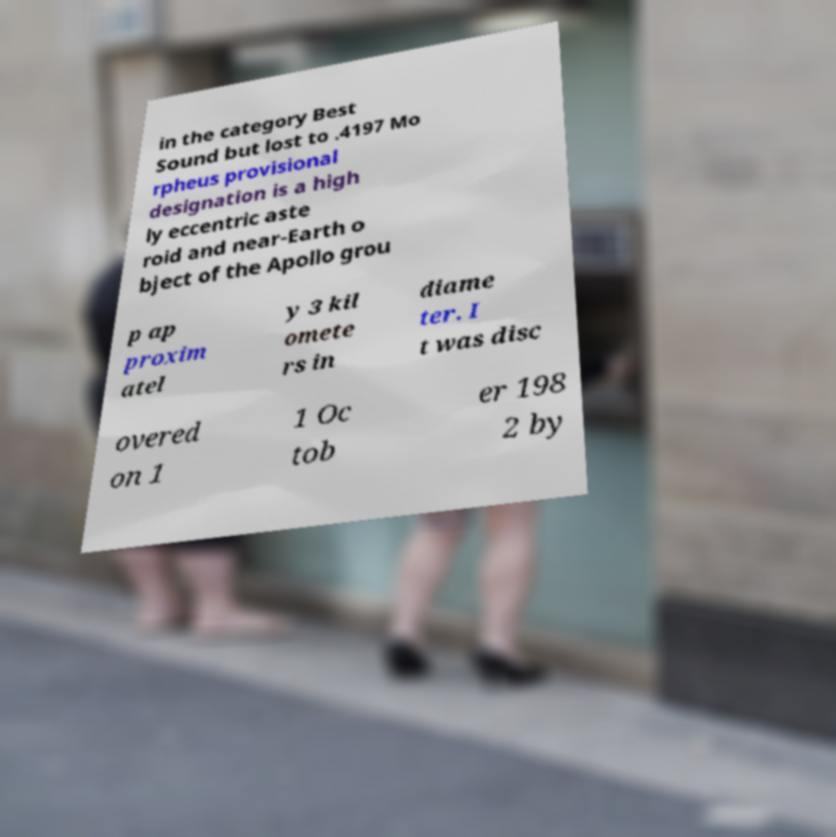What messages or text are displayed in this image? I need them in a readable, typed format. in the category Best Sound but lost to .4197 Mo rpheus provisional designation is a high ly eccentric aste roid and near-Earth o bject of the Apollo grou p ap proxim atel y 3 kil omete rs in diame ter. I t was disc overed on 1 1 Oc tob er 198 2 by 